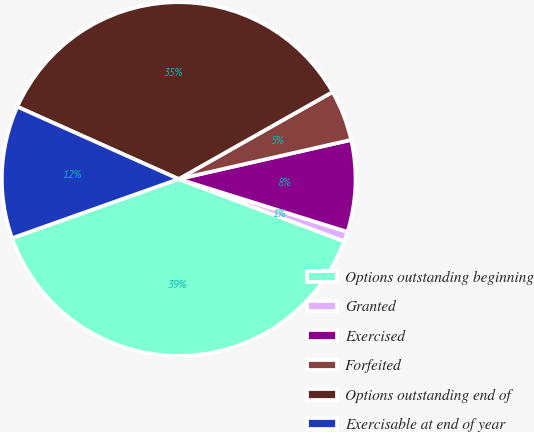Convert chart. <chart><loc_0><loc_0><loc_500><loc_500><pie_chart><fcel>Options outstanding beginning<fcel>Granted<fcel>Exercised<fcel>Forfeited<fcel>Options outstanding end of<fcel>Exercisable at end of year<nl><fcel>38.85%<fcel>0.9%<fcel>8.38%<fcel>4.64%<fcel>35.1%<fcel>12.13%<nl></chart> 